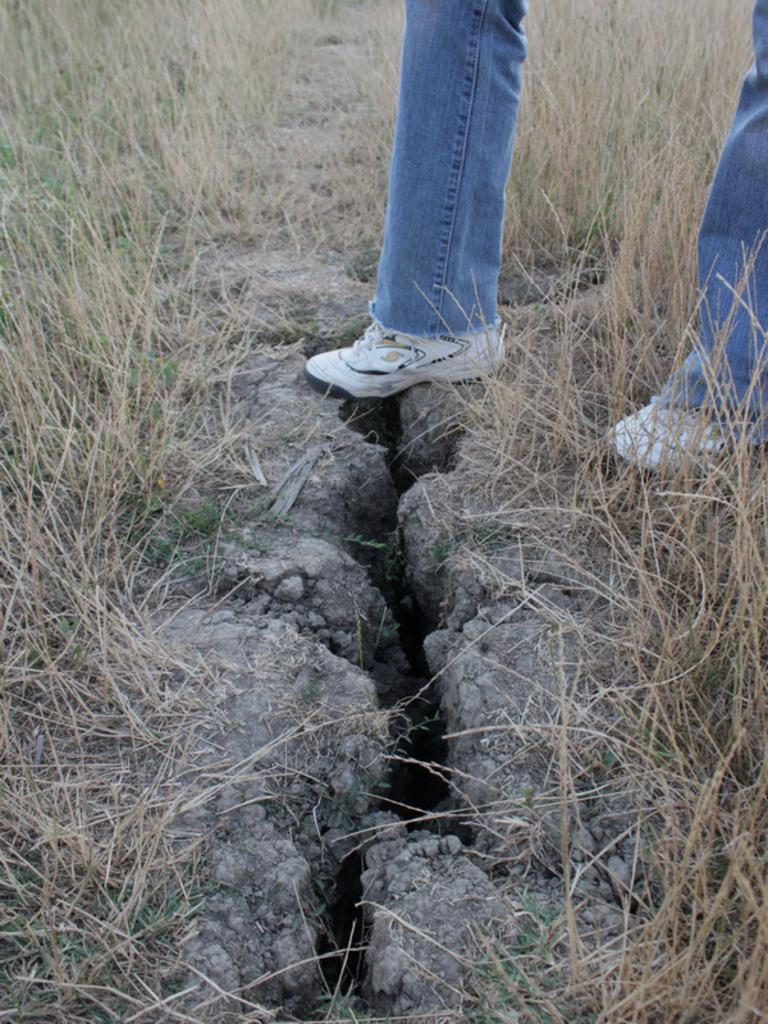Describe this image in one or two sentences. In this image, I can see the legs of a person with shoes. There is the grass. 